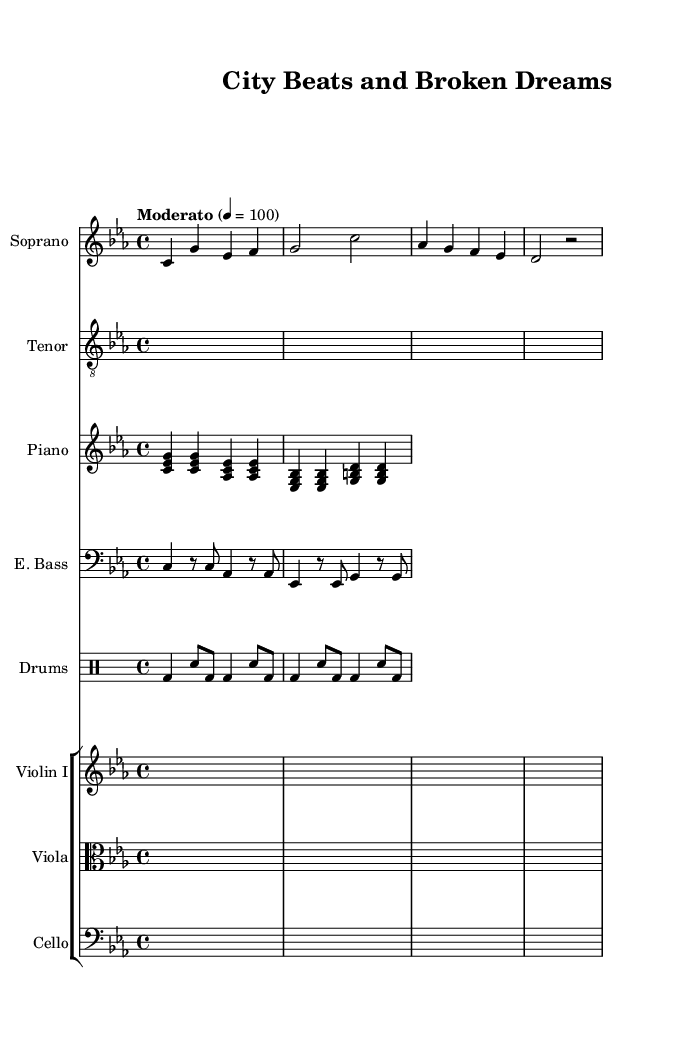What is the key signature of this music? The key signature is C minor, which has three flats (B♭, E♭, A♭). This is indicated at the beginning of the score after the clef.
Answer: C minor What is the time signature of this music? The time signature is 4/4, which is indicated at the beginning of the score. It shows that there are four beats in each measure and the quarter note gets one beat.
Answer: 4/4 What is the tempo marking for this piece? The tempo marking is "Moderato," which indicates a moderate speed, typically around 100 beats per minute. It is usually found at the beginning of the score.
Answer: Moderato How many instruments are featured in this score? The score features a total of seven instruments: Soprano, Tenor (rap), Piano, Electric Bass, Drum Set, Violin, Viola, and Cello. This can be seen in the staff list provided within the score.
Answer: Seven What style of singing is used by the tenor? The tenor part is specified as "treble_8" which indicates the use of a rap style, different from traditional operatic singing. It implies that the tenor's role involves rhythmic spoken word rather than melodic singing.
Answer: Rhythmic spoken word What is the first lyric of the soprano? The first lyric of the soprano is "In the sha," indicating the beginning of the vocal line. This can be seen directly under the Soprano staff where the lyrics are written in lyric mode.
Answer: In the sha What does the drum set rhythm consist of? The drum set rhythm consists of a bass drum and snare drum alternating in eighth and quarter note patterns. This rhythmic pattern can be identified in the drummode section of the score.
Answer: Bass and snare alternation 